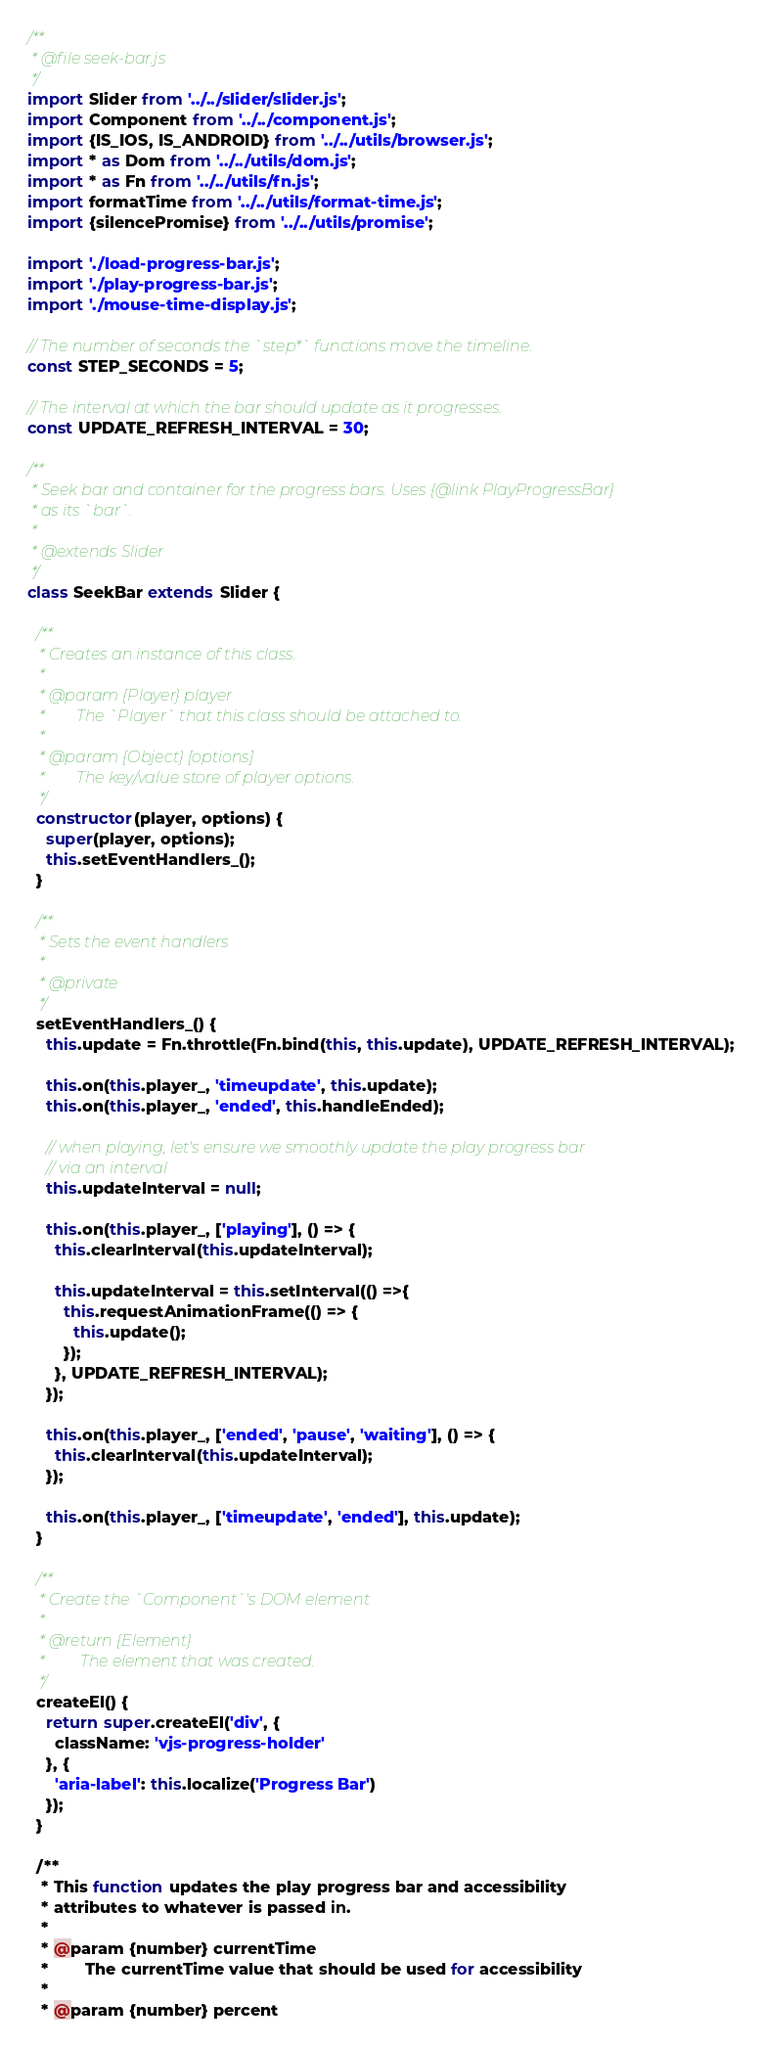<code> <loc_0><loc_0><loc_500><loc_500><_JavaScript_>/**
 * @file seek-bar.js
 */
import Slider from '../../slider/slider.js';
import Component from '../../component.js';
import {IS_IOS, IS_ANDROID} from '../../utils/browser.js';
import * as Dom from '../../utils/dom.js';
import * as Fn from '../../utils/fn.js';
import formatTime from '../../utils/format-time.js';
import {silencePromise} from '../../utils/promise';

import './load-progress-bar.js';
import './play-progress-bar.js';
import './mouse-time-display.js';

// The number of seconds the `step*` functions move the timeline.
const STEP_SECONDS = 5;

// The interval at which the bar should update as it progresses.
const UPDATE_REFRESH_INTERVAL = 30;

/**
 * Seek bar and container for the progress bars. Uses {@link PlayProgressBar}
 * as its `bar`.
 *
 * @extends Slider
 */
class SeekBar extends Slider {

  /**
   * Creates an instance of this class.
   *
   * @param {Player} player
   *        The `Player` that this class should be attached to.
   *
   * @param {Object} [options]
   *        The key/value store of player options.
   */
  constructor(player, options) {
    super(player, options);
    this.setEventHandlers_();
  }

  /**
   * Sets the event handlers
   *
   * @private
   */
  setEventHandlers_() {
    this.update = Fn.throttle(Fn.bind(this, this.update), UPDATE_REFRESH_INTERVAL);

    this.on(this.player_, 'timeupdate', this.update);
    this.on(this.player_, 'ended', this.handleEnded);

    // when playing, let's ensure we smoothly update the play progress bar
    // via an interval
    this.updateInterval = null;

    this.on(this.player_, ['playing'], () => {
      this.clearInterval(this.updateInterval);

      this.updateInterval = this.setInterval(() =>{
        this.requestAnimationFrame(() => {
          this.update();
        });
      }, UPDATE_REFRESH_INTERVAL);
    });

    this.on(this.player_, ['ended', 'pause', 'waiting'], () => {
      this.clearInterval(this.updateInterval);
    });

    this.on(this.player_, ['timeupdate', 'ended'], this.update);
  }

  /**
   * Create the `Component`'s DOM element
   *
   * @return {Element}
   *         The element that was created.
   */
  createEl() {
    return super.createEl('div', {
      className: 'vjs-progress-holder'
    }, {
      'aria-label': this.localize('Progress Bar')
    });
  }

  /**
   * This function updates the play progress bar and accessibility
   * attributes to whatever is passed in.
   *
   * @param {number} currentTime
   *        The currentTime value that should be used for accessibility
   *
   * @param {number} percent</code> 